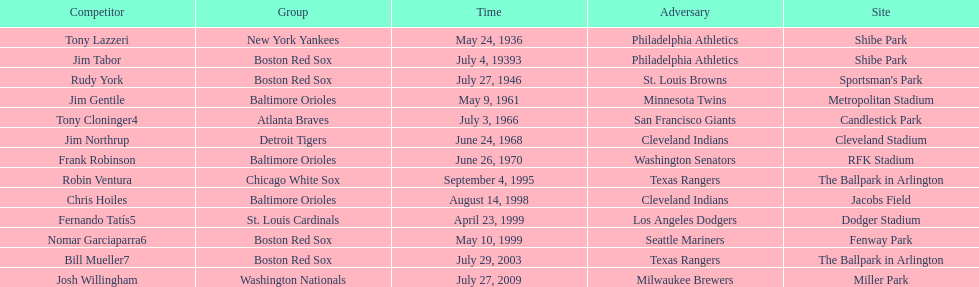Which teams faced off at miller park? Washington Nationals, Milwaukee Brewers. 